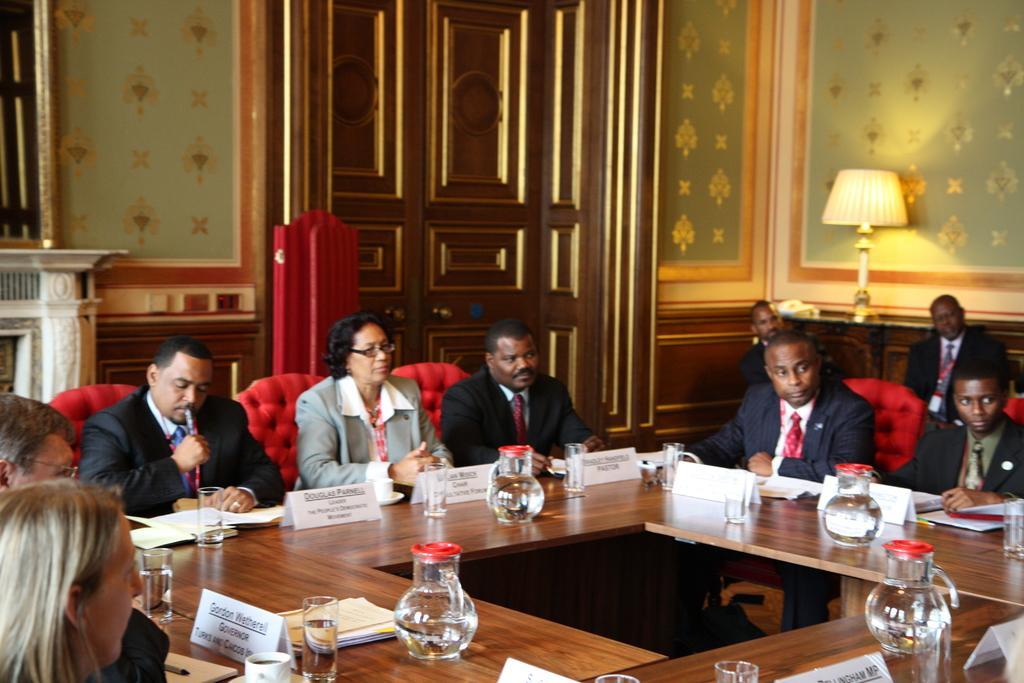Please provide a concise description of this image. This image is taken indoors. In the background there is a wall with a door and a few paintings on it. There is a lamp on the table. At the bottom of the image there is a table with a few name boards, papers, glasses with water, jugs with water, a cup of tea and a few things on it. In the middle of the image many people are sitting on the chairs. 